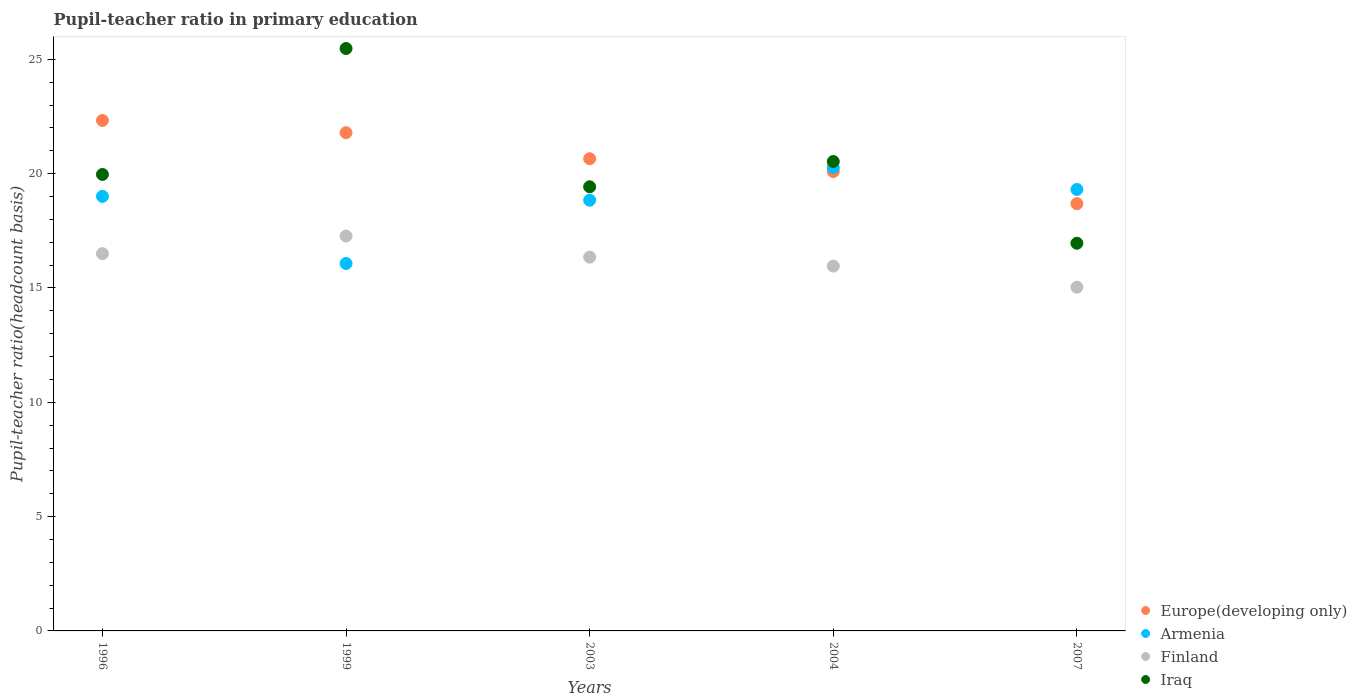What is the pupil-teacher ratio in primary education in Finland in 2003?
Give a very brief answer. 16.35. Across all years, what is the maximum pupil-teacher ratio in primary education in Europe(developing only)?
Keep it short and to the point. 22.33. Across all years, what is the minimum pupil-teacher ratio in primary education in Finland?
Your response must be concise. 15.03. What is the total pupil-teacher ratio in primary education in Europe(developing only) in the graph?
Your answer should be compact. 103.55. What is the difference between the pupil-teacher ratio in primary education in Armenia in 1999 and that in 2004?
Provide a short and direct response. -4.19. What is the difference between the pupil-teacher ratio in primary education in Finland in 2003 and the pupil-teacher ratio in primary education in Europe(developing only) in 2007?
Your answer should be very brief. -2.34. What is the average pupil-teacher ratio in primary education in Armenia per year?
Your answer should be compact. 18.7. In the year 2003, what is the difference between the pupil-teacher ratio in primary education in Iraq and pupil-teacher ratio in primary education in Europe(developing only)?
Offer a terse response. -1.23. In how many years, is the pupil-teacher ratio in primary education in Iraq greater than 23?
Offer a terse response. 1. What is the ratio of the pupil-teacher ratio in primary education in Iraq in 1996 to that in 1999?
Give a very brief answer. 0.78. What is the difference between the highest and the second highest pupil-teacher ratio in primary education in Europe(developing only)?
Your answer should be very brief. 0.54. What is the difference between the highest and the lowest pupil-teacher ratio in primary education in Europe(developing only)?
Offer a terse response. 3.64. In how many years, is the pupil-teacher ratio in primary education in Europe(developing only) greater than the average pupil-teacher ratio in primary education in Europe(developing only) taken over all years?
Provide a succinct answer. 2. Is it the case that in every year, the sum of the pupil-teacher ratio in primary education in Finland and pupil-teacher ratio in primary education in Armenia  is greater than the sum of pupil-teacher ratio in primary education in Iraq and pupil-teacher ratio in primary education in Europe(developing only)?
Offer a terse response. No. Is the pupil-teacher ratio in primary education in Iraq strictly greater than the pupil-teacher ratio in primary education in Finland over the years?
Make the answer very short. Yes. How many years are there in the graph?
Offer a terse response. 5. Does the graph contain grids?
Your answer should be very brief. No. Where does the legend appear in the graph?
Ensure brevity in your answer.  Bottom right. What is the title of the graph?
Make the answer very short. Pupil-teacher ratio in primary education. What is the label or title of the X-axis?
Give a very brief answer. Years. What is the label or title of the Y-axis?
Provide a short and direct response. Pupil-teacher ratio(headcount basis). What is the Pupil-teacher ratio(headcount basis) in Europe(developing only) in 1996?
Your answer should be compact. 22.33. What is the Pupil-teacher ratio(headcount basis) of Armenia in 1996?
Keep it short and to the point. 19.01. What is the Pupil-teacher ratio(headcount basis) in Finland in 1996?
Offer a very short reply. 16.5. What is the Pupil-teacher ratio(headcount basis) of Iraq in 1996?
Offer a very short reply. 19.96. What is the Pupil-teacher ratio(headcount basis) in Europe(developing only) in 1999?
Offer a terse response. 21.79. What is the Pupil-teacher ratio(headcount basis) of Armenia in 1999?
Ensure brevity in your answer.  16.07. What is the Pupil-teacher ratio(headcount basis) of Finland in 1999?
Your answer should be very brief. 17.27. What is the Pupil-teacher ratio(headcount basis) of Iraq in 1999?
Your answer should be very brief. 25.47. What is the Pupil-teacher ratio(headcount basis) of Europe(developing only) in 2003?
Your answer should be very brief. 20.65. What is the Pupil-teacher ratio(headcount basis) of Armenia in 2003?
Your answer should be compact. 18.84. What is the Pupil-teacher ratio(headcount basis) in Finland in 2003?
Provide a succinct answer. 16.35. What is the Pupil-teacher ratio(headcount basis) of Iraq in 2003?
Give a very brief answer. 19.42. What is the Pupil-teacher ratio(headcount basis) of Europe(developing only) in 2004?
Make the answer very short. 20.09. What is the Pupil-teacher ratio(headcount basis) of Armenia in 2004?
Your response must be concise. 20.26. What is the Pupil-teacher ratio(headcount basis) of Finland in 2004?
Provide a succinct answer. 15.96. What is the Pupil-teacher ratio(headcount basis) of Iraq in 2004?
Provide a short and direct response. 20.53. What is the Pupil-teacher ratio(headcount basis) of Europe(developing only) in 2007?
Your response must be concise. 18.69. What is the Pupil-teacher ratio(headcount basis) in Armenia in 2007?
Provide a short and direct response. 19.31. What is the Pupil-teacher ratio(headcount basis) in Finland in 2007?
Keep it short and to the point. 15.03. What is the Pupil-teacher ratio(headcount basis) in Iraq in 2007?
Provide a succinct answer. 16.96. Across all years, what is the maximum Pupil-teacher ratio(headcount basis) of Europe(developing only)?
Provide a succinct answer. 22.33. Across all years, what is the maximum Pupil-teacher ratio(headcount basis) of Armenia?
Your answer should be very brief. 20.26. Across all years, what is the maximum Pupil-teacher ratio(headcount basis) in Finland?
Your answer should be compact. 17.27. Across all years, what is the maximum Pupil-teacher ratio(headcount basis) of Iraq?
Offer a terse response. 25.47. Across all years, what is the minimum Pupil-teacher ratio(headcount basis) of Europe(developing only)?
Make the answer very short. 18.69. Across all years, what is the minimum Pupil-teacher ratio(headcount basis) in Armenia?
Keep it short and to the point. 16.07. Across all years, what is the minimum Pupil-teacher ratio(headcount basis) in Finland?
Offer a very short reply. 15.03. Across all years, what is the minimum Pupil-teacher ratio(headcount basis) in Iraq?
Your response must be concise. 16.96. What is the total Pupil-teacher ratio(headcount basis) in Europe(developing only) in the graph?
Your response must be concise. 103.55. What is the total Pupil-teacher ratio(headcount basis) of Armenia in the graph?
Provide a short and direct response. 93.48. What is the total Pupil-teacher ratio(headcount basis) of Finland in the graph?
Your answer should be very brief. 81.11. What is the total Pupil-teacher ratio(headcount basis) of Iraq in the graph?
Offer a very short reply. 102.35. What is the difference between the Pupil-teacher ratio(headcount basis) in Europe(developing only) in 1996 and that in 1999?
Provide a succinct answer. 0.54. What is the difference between the Pupil-teacher ratio(headcount basis) in Armenia in 1996 and that in 1999?
Provide a short and direct response. 2.94. What is the difference between the Pupil-teacher ratio(headcount basis) in Finland in 1996 and that in 1999?
Offer a very short reply. -0.77. What is the difference between the Pupil-teacher ratio(headcount basis) of Iraq in 1996 and that in 1999?
Keep it short and to the point. -5.51. What is the difference between the Pupil-teacher ratio(headcount basis) of Europe(developing only) in 1996 and that in 2003?
Ensure brevity in your answer.  1.67. What is the difference between the Pupil-teacher ratio(headcount basis) of Armenia in 1996 and that in 2003?
Offer a very short reply. 0.17. What is the difference between the Pupil-teacher ratio(headcount basis) in Finland in 1996 and that in 2003?
Make the answer very short. 0.15. What is the difference between the Pupil-teacher ratio(headcount basis) of Iraq in 1996 and that in 2003?
Your response must be concise. 0.54. What is the difference between the Pupil-teacher ratio(headcount basis) of Europe(developing only) in 1996 and that in 2004?
Make the answer very short. 2.24. What is the difference between the Pupil-teacher ratio(headcount basis) in Armenia in 1996 and that in 2004?
Provide a succinct answer. -1.26. What is the difference between the Pupil-teacher ratio(headcount basis) in Finland in 1996 and that in 2004?
Provide a succinct answer. 0.54. What is the difference between the Pupil-teacher ratio(headcount basis) in Iraq in 1996 and that in 2004?
Provide a short and direct response. -0.57. What is the difference between the Pupil-teacher ratio(headcount basis) in Europe(developing only) in 1996 and that in 2007?
Your response must be concise. 3.64. What is the difference between the Pupil-teacher ratio(headcount basis) in Armenia in 1996 and that in 2007?
Your answer should be compact. -0.3. What is the difference between the Pupil-teacher ratio(headcount basis) of Finland in 1996 and that in 2007?
Your answer should be very brief. 1.47. What is the difference between the Pupil-teacher ratio(headcount basis) in Iraq in 1996 and that in 2007?
Give a very brief answer. 3.01. What is the difference between the Pupil-teacher ratio(headcount basis) of Europe(developing only) in 1999 and that in 2003?
Your answer should be compact. 1.14. What is the difference between the Pupil-teacher ratio(headcount basis) of Armenia in 1999 and that in 2003?
Offer a terse response. -2.77. What is the difference between the Pupil-teacher ratio(headcount basis) of Finland in 1999 and that in 2003?
Your response must be concise. 0.92. What is the difference between the Pupil-teacher ratio(headcount basis) of Iraq in 1999 and that in 2003?
Your response must be concise. 6.05. What is the difference between the Pupil-teacher ratio(headcount basis) of Europe(developing only) in 1999 and that in 2004?
Provide a short and direct response. 1.7. What is the difference between the Pupil-teacher ratio(headcount basis) of Armenia in 1999 and that in 2004?
Offer a very short reply. -4.19. What is the difference between the Pupil-teacher ratio(headcount basis) in Finland in 1999 and that in 2004?
Offer a very short reply. 1.31. What is the difference between the Pupil-teacher ratio(headcount basis) of Iraq in 1999 and that in 2004?
Offer a terse response. 4.94. What is the difference between the Pupil-teacher ratio(headcount basis) in Europe(developing only) in 1999 and that in 2007?
Offer a very short reply. 3.1. What is the difference between the Pupil-teacher ratio(headcount basis) of Armenia in 1999 and that in 2007?
Ensure brevity in your answer.  -3.24. What is the difference between the Pupil-teacher ratio(headcount basis) in Finland in 1999 and that in 2007?
Offer a very short reply. 2.24. What is the difference between the Pupil-teacher ratio(headcount basis) in Iraq in 1999 and that in 2007?
Make the answer very short. 8.52. What is the difference between the Pupil-teacher ratio(headcount basis) of Europe(developing only) in 2003 and that in 2004?
Ensure brevity in your answer.  0.56. What is the difference between the Pupil-teacher ratio(headcount basis) of Armenia in 2003 and that in 2004?
Make the answer very short. -1.43. What is the difference between the Pupil-teacher ratio(headcount basis) of Finland in 2003 and that in 2004?
Offer a terse response. 0.39. What is the difference between the Pupil-teacher ratio(headcount basis) in Iraq in 2003 and that in 2004?
Keep it short and to the point. -1.1. What is the difference between the Pupil-teacher ratio(headcount basis) in Europe(developing only) in 2003 and that in 2007?
Offer a very short reply. 1.97. What is the difference between the Pupil-teacher ratio(headcount basis) of Armenia in 2003 and that in 2007?
Your response must be concise. -0.47. What is the difference between the Pupil-teacher ratio(headcount basis) in Finland in 2003 and that in 2007?
Give a very brief answer. 1.31. What is the difference between the Pupil-teacher ratio(headcount basis) in Iraq in 2003 and that in 2007?
Your answer should be compact. 2.47. What is the difference between the Pupil-teacher ratio(headcount basis) in Europe(developing only) in 2004 and that in 2007?
Provide a short and direct response. 1.4. What is the difference between the Pupil-teacher ratio(headcount basis) in Armenia in 2004 and that in 2007?
Offer a very short reply. 0.95. What is the difference between the Pupil-teacher ratio(headcount basis) in Finland in 2004 and that in 2007?
Make the answer very short. 0.92. What is the difference between the Pupil-teacher ratio(headcount basis) in Iraq in 2004 and that in 2007?
Provide a succinct answer. 3.57. What is the difference between the Pupil-teacher ratio(headcount basis) in Europe(developing only) in 1996 and the Pupil-teacher ratio(headcount basis) in Armenia in 1999?
Provide a succinct answer. 6.26. What is the difference between the Pupil-teacher ratio(headcount basis) of Europe(developing only) in 1996 and the Pupil-teacher ratio(headcount basis) of Finland in 1999?
Offer a very short reply. 5.06. What is the difference between the Pupil-teacher ratio(headcount basis) of Europe(developing only) in 1996 and the Pupil-teacher ratio(headcount basis) of Iraq in 1999?
Offer a very short reply. -3.15. What is the difference between the Pupil-teacher ratio(headcount basis) of Armenia in 1996 and the Pupil-teacher ratio(headcount basis) of Finland in 1999?
Your answer should be compact. 1.74. What is the difference between the Pupil-teacher ratio(headcount basis) of Armenia in 1996 and the Pupil-teacher ratio(headcount basis) of Iraq in 1999?
Keep it short and to the point. -6.47. What is the difference between the Pupil-teacher ratio(headcount basis) in Finland in 1996 and the Pupil-teacher ratio(headcount basis) in Iraq in 1999?
Your answer should be compact. -8.97. What is the difference between the Pupil-teacher ratio(headcount basis) in Europe(developing only) in 1996 and the Pupil-teacher ratio(headcount basis) in Armenia in 2003?
Your answer should be compact. 3.49. What is the difference between the Pupil-teacher ratio(headcount basis) in Europe(developing only) in 1996 and the Pupil-teacher ratio(headcount basis) in Finland in 2003?
Your response must be concise. 5.98. What is the difference between the Pupil-teacher ratio(headcount basis) of Europe(developing only) in 1996 and the Pupil-teacher ratio(headcount basis) of Iraq in 2003?
Keep it short and to the point. 2.9. What is the difference between the Pupil-teacher ratio(headcount basis) in Armenia in 1996 and the Pupil-teacher ratio(headcount basis) in Finland in 2003?
Offer a terse response. 2.66. What is the difference between the Pupil-teacher ratio(headcount basis) of Armenia in 1996 and the Pupil-teacher ratio(headcount basis) of Iraq in 2003?
Keep it short and to the point. -0.42. What is the difference between the Pupil-teacher ratio(headcount basis) in Finland in 1996 and the Pupil-teacher ratio(headcount basis) in Iraq in 2003?
Offer a very short reply. -2.92. What is the difference between the Pupil-teacher ratio(headcount basis) of Europe(developing only) in 1996 and the Pupil-teacher ratio(headcount basis) of Armenia in 2004?
Ensure brevity in your answer.  2.06. What is the difference between the Pupil-teacher ratio(headcount basis) in Europe(developing only) in 1996 and the Pupil-teacher ratio(headcount basis) in Finland in 2004?
Your answer should be compact. 6.37. What is the difference between the Pupil-teacher ratio(headcount basis) of Europe(developing only) in 1996 and the Pupil-teacher ratio(headcount basis) of Iraq in 2004?
Your response must be concise. 1.8. What is the difference between the Pupil-teacher ratio(headcount basis) in Armenia in 1996 and the Pupil-teacher ratio(headcount basis) in Finland in 2004?
Keep it short and to the point. 3.05. What is the difference between the Pupil-teacher ratio(headcount basis) in Armenia in 1996 and the Pupil-teacher ratio(headcount basis) in Iraq in 2004?
Keep it short and to the point. -1.52. What is the difference between the Pupil-teacher ratio(headcount basis) in Finland in 1996 and the Pupil-teacher ratio(headcount basis) in Iraq in 2004?
Provide a short and direct response. -4.03. What is the difference between the Pupil-teacher ratio(headcount basis) in Europe(developing only) in 1996 and the Pupil-teacher ratio(headcount basis) in Armenia in 2007?
Give a very brief answer. 3.02. What is the difference between the Pupil-teacher ratio(headcount basis) in Europe(developing only) in 1996 and the Pupil-teacher ratio(headcount basis) in Finland in 2007?
Provide a succinct answer. 7.29. What is the difference between the Pupil-teacher ratio(headcount basis) in Europe(developing only) in 1996 and the Pupil-teacher ratio(headcount basis) in Iraq in 2007?
Your answer should be compact. 5.37. What is the difference between the Pupil-teacher ratio(headcount basis) in Armenia in 1996 and the Pupil-teacher ratio(headcount basis) in Finland in 2007?
Offer a terse response. 3.97. What is the difference between the Pupil-teacher ratio(headcount basis) in Armenia in 1996 and the Pupil-teacher ratio(headcount basis) in Iraq in 2007?
Offer a very short reply. 2.05. What is the difference between the Pupil-teacher ratio(headcount basis) in Finland in 1996 and the Pupil-teacher ratio(headcount basis) in Iraq in 2007?
Your response must be concise. -0.45. What is the difference between the Pupil-teacher ratio(headcount basis) in Europe(developing only) in 1999 and the Pupil-teacher ratio(headcount basis) in Armenia in 2003?
Provide a short and direct response. 2.95. What is the difference between the Pupil-teacher ratio(headcount basis) in Europe(developing only) in 1999 and the Pupil-teacher ratio(headcount basis) in Finland in 2003?
Keep it short and to the point. 5.44. What is the difference between the Pupil-teacher ratio(headcount basis) in Europe(developing only) in 1999 and the Pupil-teacher ratio(headcount basis) in Iraq in 2003?
Make the answer very short. 2.37. What is the difference between the Pupil-teacher ratio(headcount basis) in Armenia in 1999 and the Pupil-teacher ratio(headcount basis) in Finland in 2003?
Offer a terse response. -0.28. What is the difference between the Pupil-teacher ratio(headcount basis) of Armenia in 1999 and the Pupil-teacher ratio(headcount basis) of Iraq in 2003?
Ensure brevity in your answer.  -3.35. What is the difference between the Pupil-teacher ratio(headcount basis) in Finland in 1999 and the Pupil-teacher ratio(headcount basis) in Iraq in 2003?
Make the answer very short. -2.16. What is the difference between the Pupil-teacher ratio(headcount basis) in Europe(developing only) in 1999 and the Pupil-teacher ratio(headcount basis) in Armenia in 2004?
Offer a terse response. 1.53. What is the difference between the Pupil-teacher ratio(headcount basis) in Europe(developing only) in 1999 and the Pupil-teacher ratio(headcount basis) in Finland in 2004?
Your response must be concise. 5.83. What is the difference between the Pupil-teacher ratio(headcount basis) in Europe(developing only) in 1999 and the Pupil-teacher ratio(headcount basis) in Iraq in 2004?
Give a very brief answer. 1.26. What is the difference between the Pupil-teacher ratio(headcount basis) in Armenia in 1999 and the Pupil-teacher ratio(headcount basis) in Finland in 2004?
Provide a short and direct response. 0.11. What is the difference between the Pupil-teacher ratio(headcount basis) of Armenia in 1999 and the Pupil-teacher ratio(headcount basis) of Iraq in 2004?
Give a very brief answer. -4.46. What is the difference between the Pupil-teacher ratio(headcount basis) of Finland in 1999 and the Pupil-teacher ratio(headcount basis) of Iraq in 2004?
Your answer should be compact. -3.26. What is the difference between the Pupil-teacher ratio(headcount basis) of Europe(developing only) in 1999 and the Pupil-teacher ratio(headcount basis) of Armenia in 2007?
Provide a short and direct response. 2.48. What is the difference between the Pupil-teacher ratio(headcount basis) in Europe(developing only) in 1999 and the Pupil-teacher ratio(headcount basis) in Finland in 2007?
Offer a very short reply. 6.76. What is the difference between the Pupil-teacher ratio(headcount basis) in Europe(developing only) in 1999 and the Pupil-teacher ratio(headcount basis) in Iraq in 2007?
Keep it short and to the point. 4.83. What is the difference between the Pupil-teacher ratio(headcount basis) in Armenia in 1999 and the Pupil-teacher ratio(headcount basis) in Finland in 2007?
Provide a short and direct response. 1.04. What is the difference between the Pupil-teacher ratio(headcount basis) in Armenia in 1999 and the Pupil-teacher ratio(headcount basis) in Iraq in 2007?
Provide a succinct answer. -0.88. What is the difference between the Pupil-teacher ratio(headcount basis) of Finland in 1999 and the Pupil-teacher ratio(headcount basis) of Iraq in 2007?
Provide a short and direct response. 0.31. What is the difference between the Pupil-teacher ratio(headcount basis) of Europe(developing only) in 2003 and the Pupil-teacher ratio(headcount basis) of Armenia in 2004?
Give a very brief answer. 0.39. What is the difference between the Pupil-teacher ratio(headcount basis) of Europe(developing only) in 2003 and the Pupil-teacher ratio(headcount basis) of Finland in 2004?
Ensure brevity in your answer.  4.7. What is the difference between the Pupil-teacher ratio(headcount basis) of Europe(developing only) in 2003 and the Pupil-teacher ratio(headcount basis) of Iraq in 2004?
Your response must be concise. 0.12. What is the difference between the Pupil-teacher ratio(headcount basis) in Armenia in 2003 and the Pupil-teacher ratio(headcount basis) in Finland in 2004?
Ensure brevity in your answer.  2.88. What is the difference between the Pupil-teacher ratio(headcount basis) in Armenia in 2003 and the Pupil-teacher ratio(headcount basis) in Iraq in 2004?
Give a very brief answer. -1.69. What is the difference between the Pupil-teacher ratio(headcount basis) of Finland in 2003 and the Pupil-teacher ratio(headcount basis) of Iraq in 2004?
Provide a short and direct response. -4.18. What is the difference between the Pupil-teacher ratio(headcount basis) of Europe(developing only) in 2003 and the Pupil-teacher ratio(headcount basis) of Armenia in 2007?
Your response must be concise. 1.34. What is the difference between the Pupil-teacher ratio(headcount basis) in Europe(developing only) in 2003 and the Pupil-teacher ratio(headcount basis) in Finland in 2007?
Your answer should be very brief. 5.62. What is the difference between the Pupil-teacher ratio(headcount basis) of Europe(developing only) in 2003 and the Pupil-teacher ratio(headcount basis) of Iraq in 2007?
Offer a very short reply. 3.7. What is the difference between the Pupil-teacher ratio(headcount basis) in Armenia in 2003 and the Pupil-teacher ratio(headcount basis) in Finland in 2007?
Ensure brevity in your answer.  3.8. What is the difference between the Pupil-teacher ratio(headcount basis) in Armenia in 2003 and the Pupil-teacher ratio(headcount basis) in Iraq in 2007?
Keep it short and to the point. 1.88. What is the difference between the Pupil-teacher ratio(headcount basis) in Finland in 2003 and the Pupil-teacher ratio(headcount basis) in Iraq in 2007?
Your answer should be very brief. -0.61. What is the difference between the Pupil-teacher ratio(headcount basis) in Europe(developing only) in 2004 and the Pupil-teacher ratio(headcount basis) in Armenia in 2007?
Your response must be concise. 0.78. What is the difference between the Pupil-teacher ratio(headcount basis) in Europe(developing only) in 2004 and the Pupil-teacher ratio(headcount basis) in Finland in 2007?
Give a very brief answer. 5.06. What is the difference between the Pupil-teacher ratio(headcount basis) of Europe(developing only) in 2004 and the Pupil-teacher ratio(headcount basis) of Iraq in 2007?
Provide a succinct answer. 3.14. What is the difference between the Pupil-teacher ratio(headcount basis) of Armenia in 2004 and the Pupil-teacher ratio(headcount basis) of Finland in 2007?
Make the answer very short. 5.23. What is the difference between the Pupil-teacher ratio(headcount basis) of Armenia in 2004 and the Pupil-teacher ratio(headcount basis) of Iraq in 2007?
Ensure brevity in your answer.  3.31. What is the difference between the Pupil-teacher ratio(headcount basis) in Finland in 2004 and the Pupil-teacher ratio(headcount basis) in Iraq in 2007?
Provide a short and direct response. -1. What is the average Pupil-teacher ratio(headcount basis) in Europe(developing only) per year?
Make the answer very short. 20.71. What is the average Pupil-teacher ratio(headcount basis) in Armenia per year?
Offer a very short reply. 18.7. What is the average Pupil-teacher ratio(headcount basis) in Finland per year?
Keep it short and to the point. 16.22. What is the average Pupil-teacher ratio(headcount basis) of Iraq per year?
Ensure brevity in your answer.  20.47. In the year 1996, what is the difference between the Pupil-teacher ratio(headcount basis) of Europe(developing only) and Pupil-teacher ratio(headcount basis) of Armenia?
Your answer should be very brief. 3.32. In the year 1996, what is the difference between the Pupil-teacher ratio(headcount basis) in Europe(developing only) and Pupil-teacher ratio(headcount basis) in Finland?
Your answer should be compact. 5.83. In the year 1996, what is the difference between the Pupil-teacher ratio(headcount basis) of Europe(developing only) and Pupil-teacher ratio(headcount basis) of Iraq?
Provide a short and direct response. 2.36. In the year 1996, what is the difference between the Pupil-teacher ratio(headcount basis) of Armenia and Pupil-teacher ratio(headcount basis) of Finland?
Ensure brevity in your answer.  2.51. In the year 1996, what is the difference between the Pupil-teacher ratio(headcount basis) in Armenia and Pupil-teacher ratio(headcount basis) in Iraq?
Your answer should be compact. -0.96. In the year 1996, what is the difference between the Pupil-teacher ratio(headcount basis) in Finland and Pupil-teacher ratio(headcount basis) in Iraq?
Your response must be concise. -3.46. In the year 1999, what is the difference between the Pupil-teacher ratio(headcount basis) of Europe(developing only) and Pupil-teacher ratio(headcount basis) of Armenia?
Your answer should be very brief. 5.72. In the year 1999, what is the difference between the Pupil-teacher ratio(headcount basis) in Europe(developing only) and Pupil-teacher ratio(headcount basis) in Finland?
Provide a succinct answer. 4.52. In the year 1999, what is the difference between the Pupil-teacher ratio(headcount basis) in Europe(developing only) and Pupil-teacher ratio(headcount basis) in Iraq?
Your answer should be compact. -3.68. In the year 1999, what is the difference between the Pupil-teacher ratio(headcount basis) of Armenia and Pupil-teacher ratio(headcount basis) of Finland?
Your answer should be compact. -1.2. In the year 1999, what is the difference between the Pupil-teacher ratio(headcount basis) in Armenia and Pupil-teacher ratio(headcount basis) in Iraq?
Give a very brief answer. -9.4. In the year 1999, what is the difference between the Pupil-teacher ratio(headcount basis) in Finland and Pupil-teacher ratio(headcount basis) in Iraq?
Ensure brevity in your answer.  -8.2. In the year 2003, what is the difference between the Pupil-teacher ratio(headcount basis) in Europe(developing only) and Pupil-teacher ratio(headcount basis) in Armenia?
Provide a short and direct response. 1.82. In the year 2003, what is the difference between the Pupil-teacher ratio(headcount basis) in Europe(developing only) and Pupil-teacher ratio(headcount basis) in Finland?
Provide a succinct answer. 4.3. In the year 2003, what is the difference between the Pupil-teacher ratio(headcount basis) of Europe(developing only) and Pupil-teacher ratio(headcount basis) of Iraq?
Provide a short and direct response. 1.23. In the year 2003, what is the difference between the Pupil-teacher ratio(headcount basis) in Armenia and Pupil-teacher ratio(headcount basis) in Finland?
Your answer should be very brief. 2.49. In the year 2003, what is the difference between the Pupil-teacher ratio(headcount basis) in Armenia and Pupil-teacher ratio(headcount basis) in Iraq?
Your response must be concise. -0.59. In the year 2003, what is the difference between the Pupil-teacher ratio(headcount basis) in Finland and Pupil-teacher ratio(headcount basis) in Iraq?
Offer a very short reply. -3.08. In the year 2004, what is the difference between the Pupil-teacher ratio(headcount basis) in Europe(developing only) and Pupil-teacher ratio(headcount basis) in Armenia?
Keep it short and to the point. -0.17. In the year 2004, what is the difference between the Pupil-teacher ratio(headcount basis) of Europe(developing only) and Pupil-teacher ratio(headcount basis) of Finland?
Your answer should be very brief. 4.13. In the year 2004, what is the difference between the Pupil-teacher ratio(headcount basis) of Europe(developing only) and Pupil-teacher ratio(headcount basis) of Iraq?
Give a very brief answer. -0.44. In the year 2004, what is the difference between the Pupil-teacher ratio(headcount basis) in Armenia and Pupil-teacher ratio(headcount basis) in Finland?
Your answer should be compact. 4.31. In the year 2004, what is the difference between the Pupil-teacher ratio(headcount basis) in Armenia and Pupil-teacher ratio(headcount basis) in Iraq?
Ensure brevity in your answer.  -0.27. In the year 2004, what is the difference between the Pupil-teacher ratio(headcount basis) in Finland and Pupil-teacher ratio(headcount basis) in Iraq?
Make the answer very short. -4.57. In the year 2007, what is the difference between the Pupil-teacher ratio(headcount basis) in Europe(developing only) and Pupil-teacher ratio(headcount basis) in Armenia?
Make the answer very short. -0.62. In the year 2007, what is the difference between the Pupil-teacher ratio(headcount basis) in Europe(developing only) and Pupil-teacher ratio(headcount basis) in Finland?
Your answer should be compact. 3.65. In the year 2007, what is the difference between the Pupil-teacher ratio(headcount basis) of Europe(developing only) and Pupil-teacher ratio(headcount basis) of Iraq?
Offer a terse response. 1.73. In the year 2007, what is the difference between the Pupil-teacher ratio(headcount basis) in Armenia and Pupil-teacher ratio(headcount basis) in Finland?
Make the answer very short. 4.27. In the year 2007, what is the difference between the Pupil-teacher ratio(headcount basis) in Armenia and Pupil-teacher ratio(headcount basis) in Iraq?
Keep it short and to the point. 2.35. In the year 2007, what is the difference between the Pupil-teacher ratio(headcount basis) of Finland and Pupil-teacher ratio(headcount basis) of Iraq?
Make the answer very short. -1.92. What is the ratio of the Pupil-teacher ratio(headcount basis) of Europe(developing only) in 1996 to that in 1999?
Make the answer very short. 1.02. What is the ratio of the Pupil-teacher ratio(headcount basis) in Armenia in 1996 to that in 1999?
Provide a succinct answer. 1.18. What is the ratio of the Pupil-teacher ratio(headcount basis) in Finland in 1996 to that in 1999?
Offer a terse response. 0.96. What is the ratio of the Pupil-teacher ratio(headcount basis) of Iraq in 1996 to that in 1999?
Your answer should be very brief. 0.78. What is the ratio of the Pupil-teacher ratio(headcount basis) in Europe(developing only) in 1996 to that in 2003?
Your answer should be compact. 1.08. What is the ratio of the Pupil-teacher ratio(headcount basis) in Finland in 1996 to that in 2003?
Your answer should be compact. 1.01. What is the ratio of the Pupil-teacher ratio(headcount basis) in Iraq in 1996 to that in 2003?
Your response must be concise. 1.03. What is the ratio of the Pupil-teacher ratio(headcount basis) in Europe(developing only) in 1996 to that in 2004?
Keep it short and to the point. 1.11. What is the ratio of the Pupil-teacher ratio(headcount basis) in Armenia in 1996 to that in 2004?
Offer a terse response. 0.94. What is the ratio of the Pupil-teacher ratio(headcount basis) of Finland in 1996 to that in 2004?
Your answer should be very brief. 1.03. What is the ratio of the Pupil-teacher ratio(headcount basis) of Iraq in 1996 to that in 2004?
Ensure brevity in your answer.  0.97. What is the ratio of the Pupil-teacher ratio(headcount basis) in Europe(developing only) in 1996 to that in 2007?
Offer a terse response. 1.19. What is the ratio of the Pupil-teacher ratio(headcount basis) in Armenia in 1996 to that in 2007?
Offer a very short reply. 0.98. What is the ratio of the Pupil-teacher ratio(headcount basis) of Finland in 1996 to that in 2007?
Keep it short and to the point. 1.1. What is the ratio of the Pupil-teacher ratio(headcount basis) in Iraq in 1996 to that in 2007?
Your answer should be very brief. 1.18. What is the ratio of the Pupil-teacher ratio(headcount basis) in Europe(developing only) in 1999 to that in 2003?
Your answer should be very brief. 1.06. What is the ratio of the Pupil-teacher ratio(headcount basis) of Armenia in 1999 to that in 2003?
Keep it short and to the point. 0.85. What is the ratio of the Pupil-teacher ratio(headcount basis) in Finland in 1999 to that in 2003?
Ensure brevity in your answer.  1.06. What is the ratio of the Pupil-teacher ratio(headcount basis) in Iraq in 1999 to that in 2003?
Your answer should be compact. 1.31. What is the ratio of the Pupil-teacher ratio(headcount basis) in Europe(developing only) in 1999 to that in 2004?
Your response must be concise. 1.08. What is the ratio of the Pupil-teacher ratio(headcount basis) in Armenia in 1999 to that in 2004?
Offer a terse response. 0.79. What is the ratio of the Pupil-teacher ratio(headcount basis) in Finland in 1999 to that in 2004?
Your answer should be very brief. 1.08. What is the ratio of the Pupil-teacher ratio(headcount basis) of Iraq in 1999 to that in 2004?
Keep it short and to the point. 1.24. What is the ratio of the Pupil-teacher ratio(headcount basis) of Europe(developing only) in 1999 to that in 2007?
Offer a very short reply. 1.17. What is the ratio of the Pupil-teacher ratio(headcount basis) in Armenia in 1999 to that in 2007?
Provide a succinct answer. 0.83. What is the ratio of the Pupil-teacher ratio(headcount basis) in Finland in 1999 to that in 2007?
Provide a succinct answer. 1.15. What is the ratio of the Pupil-teacher ratio(headcount basis) in Iraq in 1999 to that in 2007?
Provide a succinct answer. 1.5. What is the ratio of the Pupil-teacher ratio(headcount basis) of Europe(developing only) in 2003 to that in 2004?
Make the answer very short. 1.03. What is the ratio of the Pupil-teacher ratio(headcount basis) of Armenia in 2003 to that in 2004?
Keep it short and to the point. 0.93. What is the ratio of the Pupil-teacher ratio(headcount basis) in Finland in 2003 to that in 2004?
Make the answer very short. 1.02. What is the ratio of the Pupil-teacher ratio(headcount basis) in Iraq in 2003 to that in 2004?
Your answer should be compact. 0.95. What is the ratio of the Pupil-teacher ratio(headcount basis) of Europe(developing only) in 2003 to that in 2007?
Give a very brief answer. 1.11. What is the ratio of the Pupil-teacher ratio(headcount basis) of Armenia in 2003 to that in 2007?
Offer a very short reply. 0.98. What is the ratio of the Pupil-teacher ratio(headcount basis) in Finland in 2003 to that in 2007?
Make the answer very short. 1.09. What is the ratio of the Pupil-teacher ratio(headcount basis) of Iraq in 2003 to that in 2007?
Ensure brevity in your answer.  1.15. What is the ratio of the Pupil-teacher ratio(headcount basis) in Europe(developing only) in 2004 to that in 2007?
Your answer should be very brief. 1.08. What is the ratio of the Pupil-teacher ratio(headcount basis) of Armenia in 2004 to that in 2007?
Give a very brief answer. 1.05. What is the ratio of the Pupil-teacher ratio(headcount basis) in Finland in 2004 to that in 2007?
Ensure brevity in your answer.  1.06. What is the ratio of the Pupil-teacher ratio(headcount basis) of Iraq in 2004 to that in 2007?
Offer a terse response. 1.21. What is the difference between the highest and the second highest Pupil-teacher ratio(headcount basis) of Europe(developing only)?
Offer a very short reply. 0.54. What is the difference between the highest and the second highest Pupil-teacher ratio(headcount basis) in Armenia?
Ensure brevity in your answer.  0.95. What is the difference between the highest and the second highest Pupil-teacher ratio(headcount basis) in Finland?
Ensure brevity in your answer.  0.77. What is the difference between the highest and the second highest Pupil-teacher ratio(headcount basis) in Iraq?
Give a very brief answer. 4.94. What is the difference between the highest and the lowest Pupil-teacher ratio(headcount basis) of Europe(developing only)?
Keep it short and to the point. 3.64. What is the difference between the highest and the lowest Pupil-teacher ratio(headcount basis) in Armenia?
Your response must be concise. 4.19. What is the difference between the highest and the lowest Pupil-teacher ratio(headcount basis) in Finland?
Offer a very short reply. 2.24. What is the difference between the highest and the lowest Pupil-teacher ratio(headcount basis) in Iraq?
Your response must be concise. 8.52. 